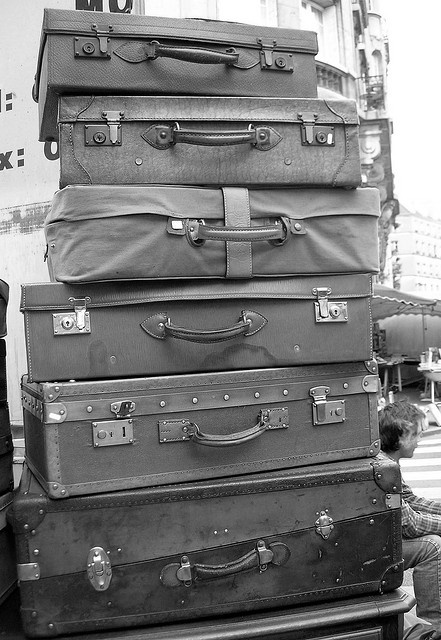Describe the objects in this image and their specific colors. I can see suitcase in lightgray, black, gray, and darkgray tones, suitcase in lightgray, gray, and black tones, suitcase in lightgray, gray, black, and darkgray tones, suitcase in lightgray, darkgray, dimgray, and black tones, and suitcase in lightgray, darkgray, dimgray, and black tones in this image. 